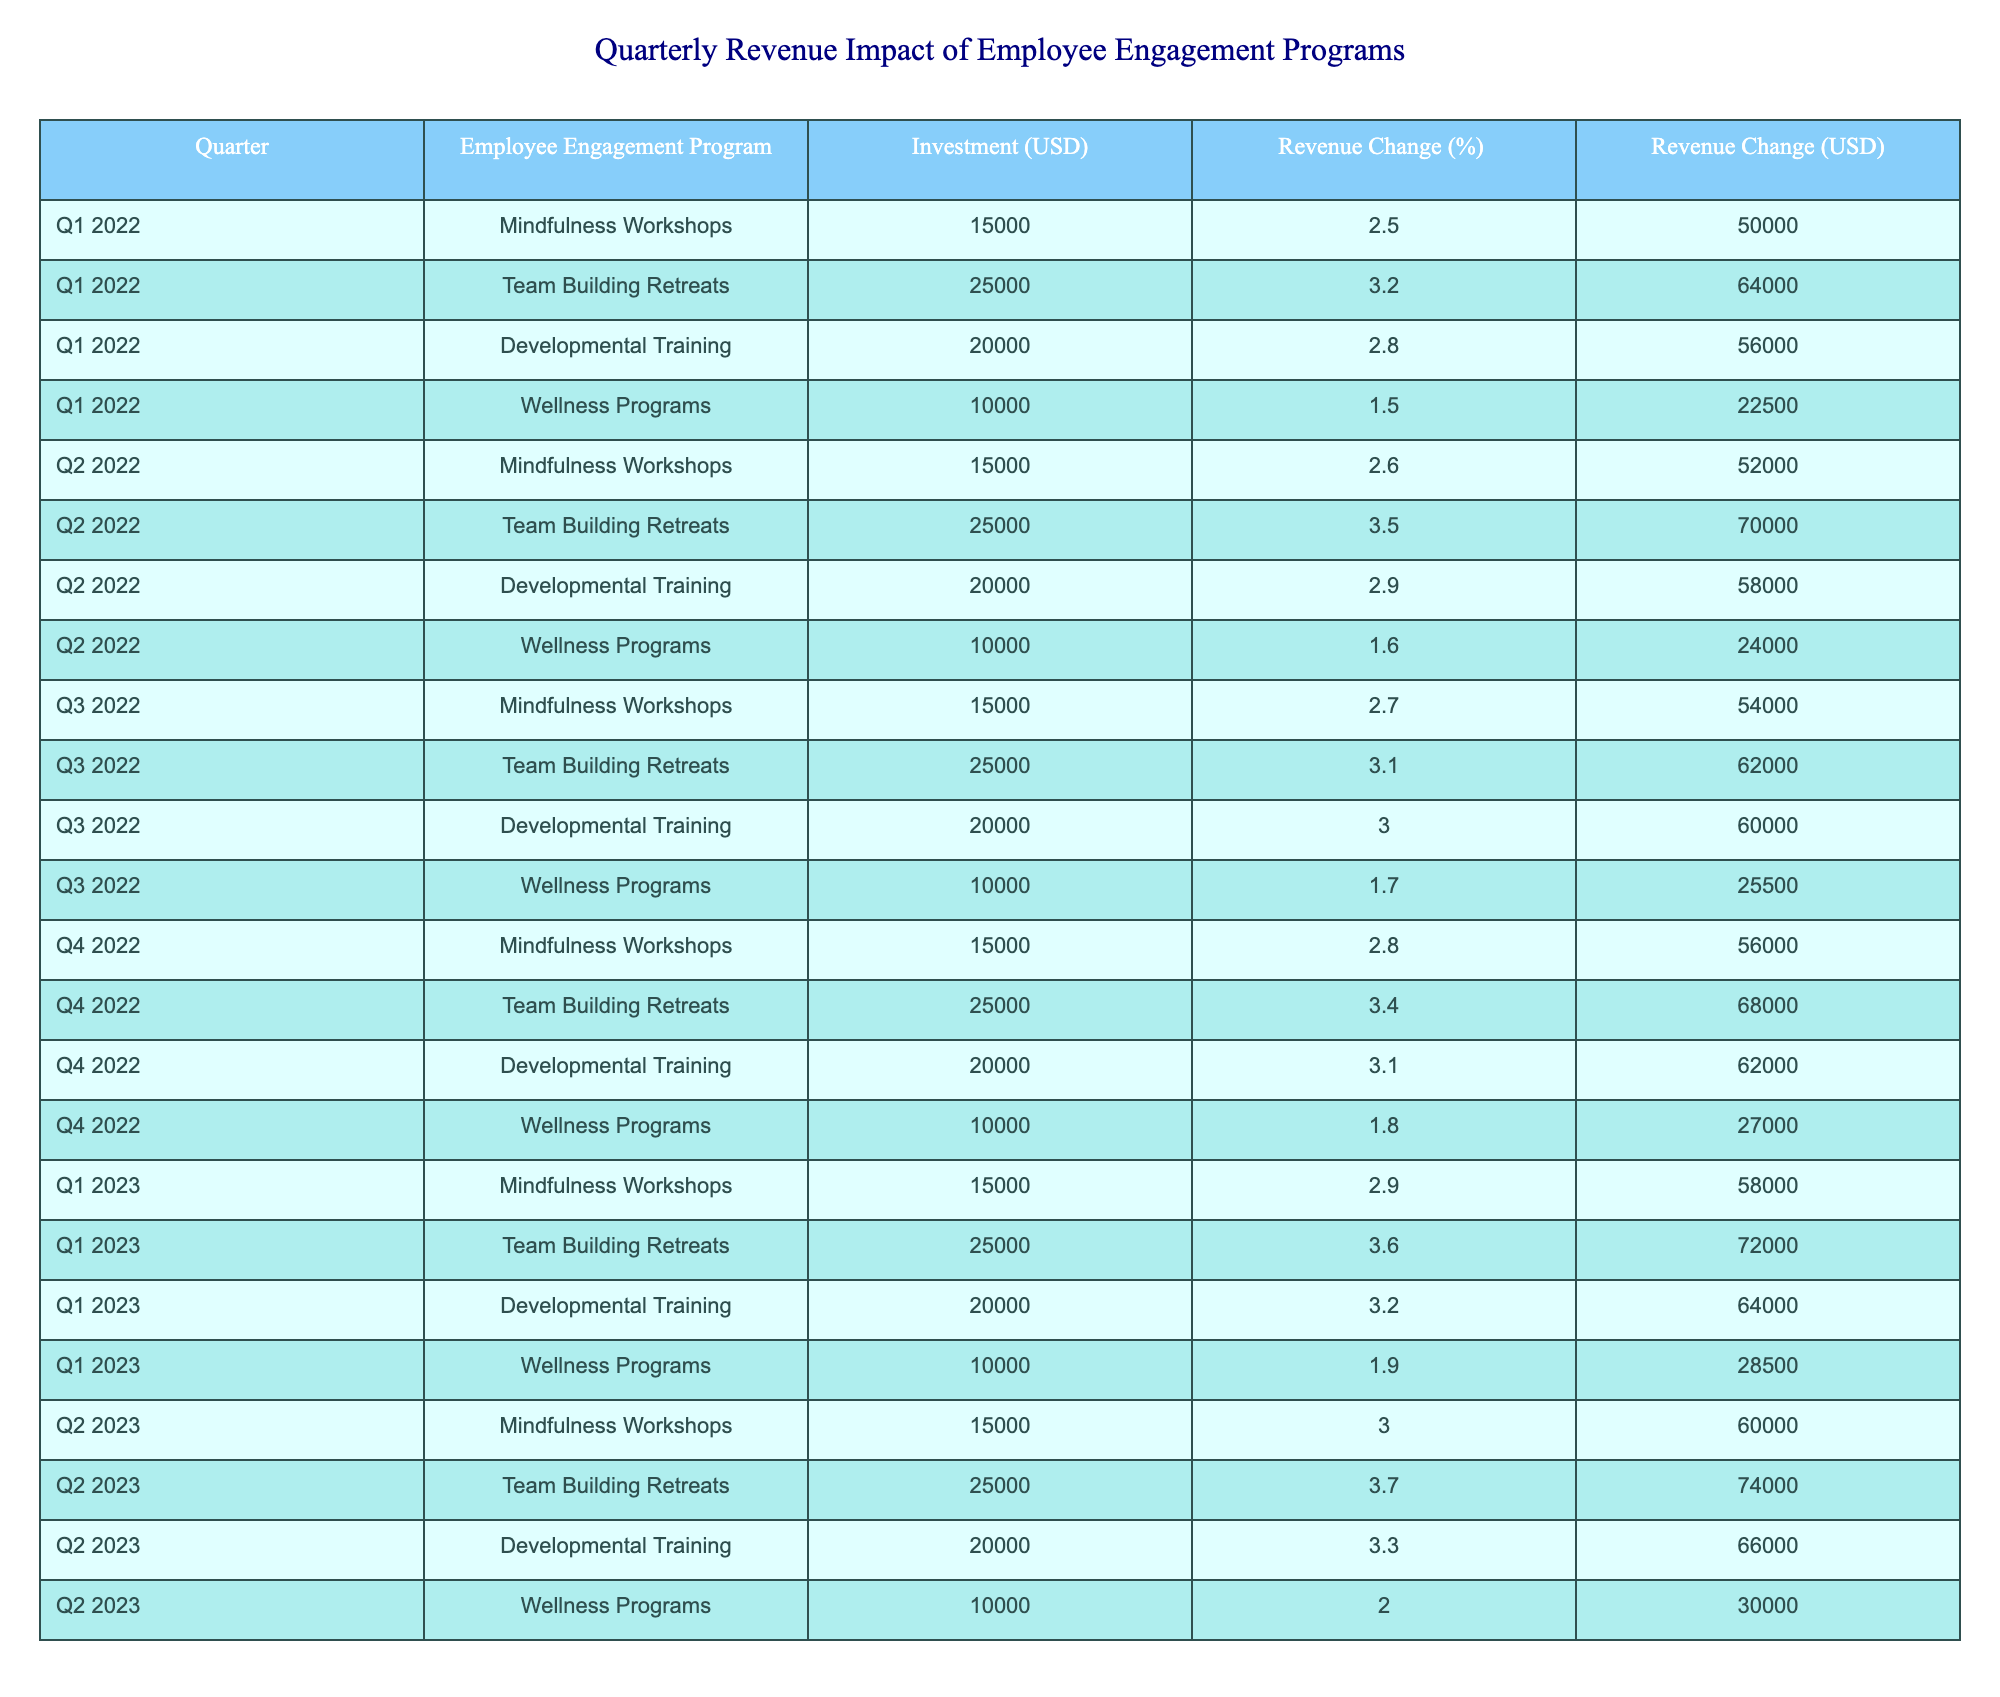What was the revenue change in Q2 2022 for the Team Building Retreats program? From the table, under Q2 2022 for the Team Building Retreats, the revenue change is listed as 3.5%.
Answer: 3.5% Which Employee Engagement Program had the highest revenue change percentage in Q3 2022? Referring to Q3 2022, the Developmental Training program had a revenue change of 3.0%, the highest among the four programs.
Answer: Developmental Training What is the total investment made on Wellness Programs from Q1 2022 to Q2 2023? The investment for Wellness Programs over the quarters is: 10,000 (Q1 2022) + 10,000 (Q2 2022) + 10,000 (Q3 2022) + 10,000 (Q4 2022) + 10,000 (Q1 2023) + 10,000 (Q2 2023) = 60,000 USD.
Answer: 60,000 USD Was there a consistent increase in revenue change percentages for Mindfulness Workshops from Q1 2022 to Q2 2023? Looking at the revenue change percentages, they were: 2.5% (Q1 2022), 2.6% (Q2 2022), 2.7% (Q3 2022), 2.8% (Q4 2022), 2.9% (Q1 2023), 3.0% (Q2 2023). This shows a continuous increase over the periods.
Answer: Yes What is the average revenue change percentage for Team Building Retreats across all quarters? The revenue change percentages for Team Building Retreats across the quarters are: 3.2% (Q1 2022), 3.5% (Q2 2022), 3.1% (Q3 2022), 3.4% (Q4 2022), 3.6% (Q1 2023), and 3.7% (Q2 2023). Adding these gives 3.2 + 3.5 + 3.1 + 3.4 + 3.6 + 3.7 = 19.5%. Dividing by 6 gives an average of 19.5 / 6 = 3.25%.
Answer: 3.25% 